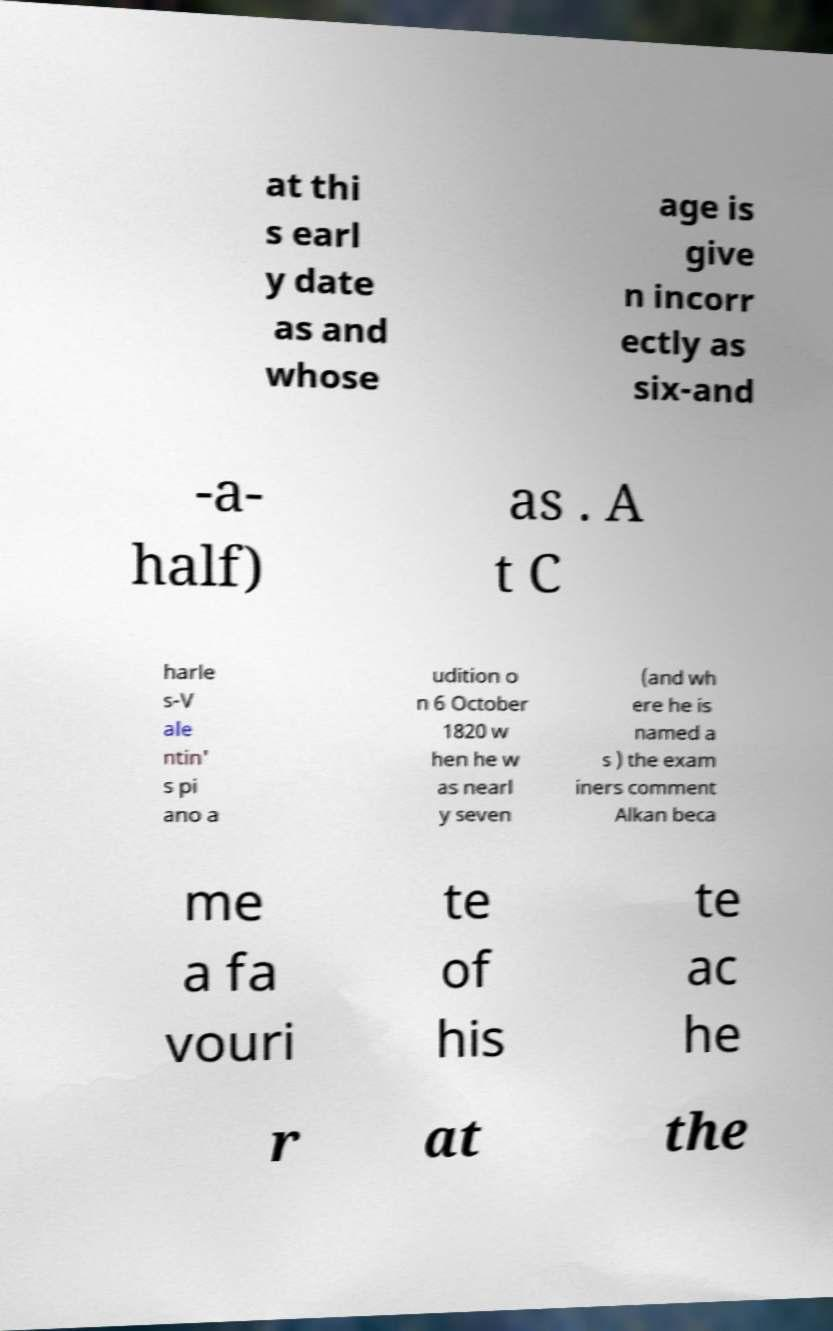There's text embedded in this image that I need extracted. Can you transcribe it verbatim? at thi s earl y date as and whose age is give n incorr ectly as six-and -a- half) as . A t C harle s-V ale ntin' s pi ano a udition o n 6 October 1820 w hen he w as nearl y seven (and wh ere he is named a s ) the exam iners comment Alkan beca me a fa vouri te of his te ac he r at the 